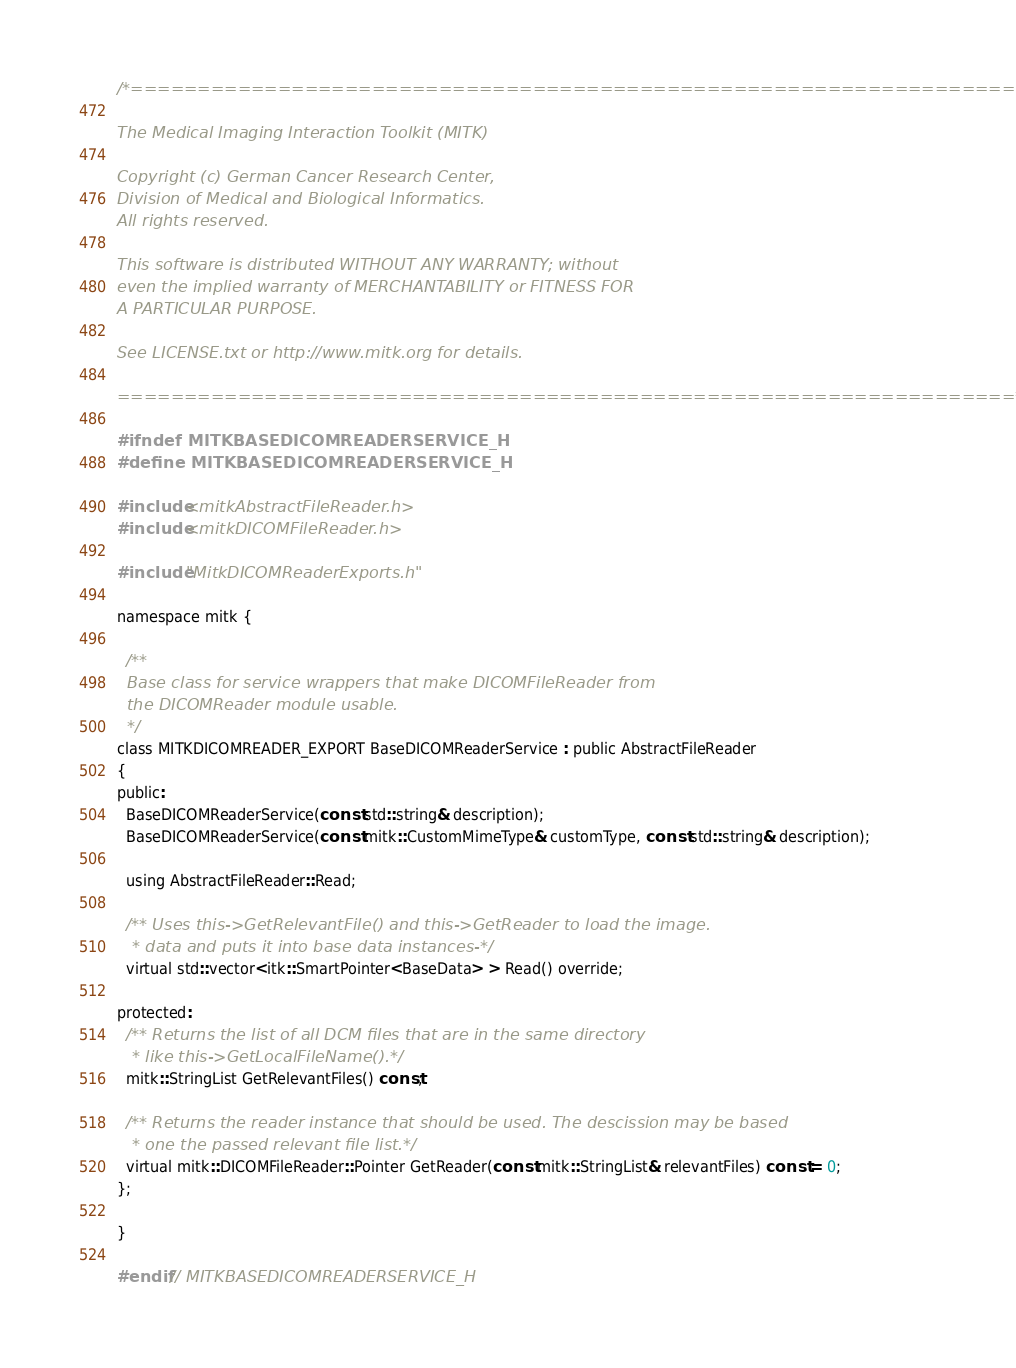Convert code to text. <code><loc_0><loc_0><loc_500><loc_500><_C_>/*===================================================================

The Medical Imaging Interaction Toolkit (MITK)

Copyright (c) German Cancer Research Center,
Division of Medical and Biological Informatics.
All rights reserved.

This software is distributed WITHOUT ANY WARRANTY; without
even the implied warranty of MERCHANTABILITY or FITNESS FOR
A PARTICULAR PURPOSE.

See LICENSE.txt or http://www.mitk.org for details.

===================================================================*/

#ifndef MITKBASEDICOMREADERSERVICE_H
#define MITKBASEDICOMREADERSERVICE_H

#include <mitkAbstractFileReader.h>
#include <mitkDICOMFileReader.h>

#include "MitkDICOMReaderExports.h"

namespace mitk {

  /**
  Base class for service wrappers that make DICOMFileReader from
  the DICOMReader module usable.
  */
class MITKDICOMREADER_EXPORT BaseDICOMReaderService : public AbstractFileReader
{
public:
  BaseDICOMReaderService(const std::string& description);
  BaseDICOMReaderService(const mitk::CustomMimeType& customType, const std::string& description);

  using AbstractFileReader::Read;

  /** Uses this->GetRelevantFile() and this->GetReader to load the image.
   * data and puts it into base data instances-*/
  virtual std::vector<itk::SmartPointer<BaseData> > Read() override;

protected:
  /** Returns the list of all DCM files that are in the same directory
   * like this->GetLocalFileName().*/
  mitk::StringList GetRelevantFiles() const;

  /** Returns the reader instance that should be used. The descission may be based
   * one the passed relevant file list.*/
  virtual mitk::DICOMFileReader::Pointer GetReader(const mitk::StringList& relevantFiles) const = 0;
};

}

#endif // MITKBASEDICOMREADERSERVICE_H
</code> 